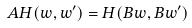<formula> <loc_0><loc_0><loc_500><loc_500>A H ( w , w ^ { \prime } ) = H ( B w , B w ^ { \prime } )</formula> 